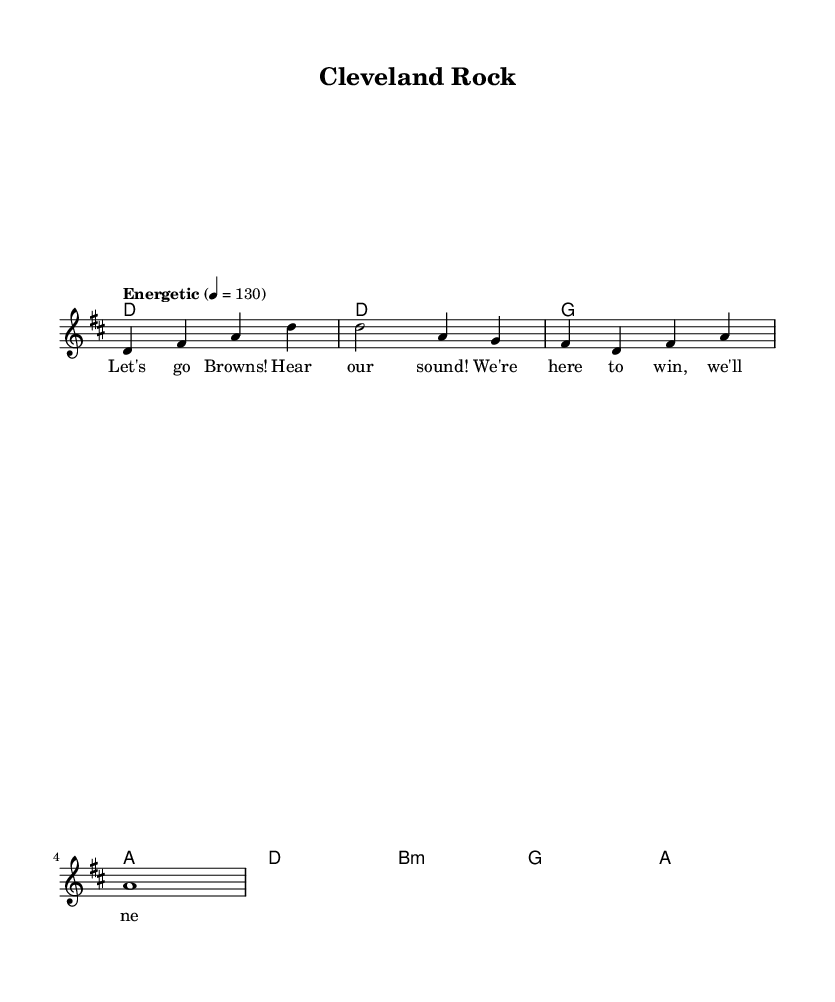What is the key signature of this music? The key signature is D major, which has two sharps: F# and C#.
Answer: D major What is the time signature of this music? The time signature is 4/4, meaning there are four beats per measure.
Answer: 4/4 What is the tempo marking indicated in the music? The tempo marking is "Energetic," which suggests a lively and upbeat performance at a pace of 130 beats per minute.
Answer: Energetic How many measures are in the melody section? There are four measures in the melody section, as separated by the vertical bar lines in the notation.
Answer: Four What is the first chord in the harmony section? The first chord in the harmony section is D major, indicated at the beginning of the chord progression.
Answer: D How do the lyrics relate to the overall theme of the song? The lyrics express excitement and determination, aligning with the pump-up nature of the music, especially related to sports enthusiasm.
Answer: Excitement What is the last note of the melody? The last note of the melody is an A, which is held for a whole note for a climactic finish.
Answer: A 